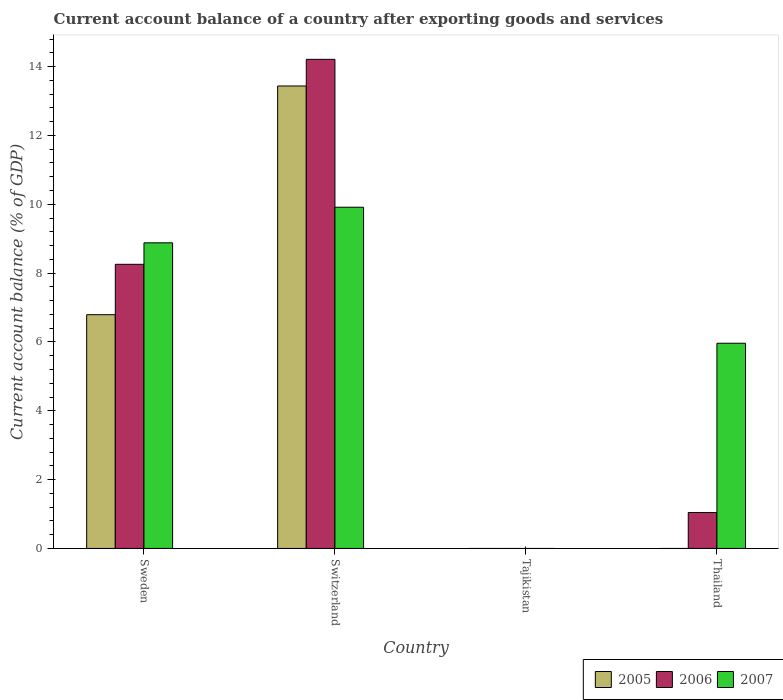How many different coloured bars are there?
Provide a short and direct response. 3. Are the number of bars on each tick of the X-axis equal?
Your answer should be very brief. No. How many bars are there on the 2nd tick from the right?
Offer a very short reply. 0. What is the label of the 4th group of bars from the left?
Ensure brevity in your answer.  Thailand. In how many cases, is the number of bars for a given country not equal to the number of legend labels?
Ensure brevity in your answer.  2. What is the account balance in 2005 in Sweden?
Offer a very short reply. 6.79. Across all countries, what is the maximum account balance in 2005?
Provide a succinct answer. 13.44. Across all countries, what is the minimum account balance in 2007?
Keep it short and to the point. 0. In which country was the account balance in 2005 maximum?
Your response must be concise. Switzerland. What is the total account balance in 2006 in the graph?
Ensure brevity in your answer.  23.51. What is the difference between the account balance in 2007 in Switzerland and that in Thailand?
Provide a short and direct response. 3.95. What is the difference between the account balance in 2006 in Switzerland and the account balance in 2005 in Thailand?
Your answer should be compact. 14.21. What is the average account balance in 2006 per country?
Offer a very short reply. 5.88. What is the difference between the account balance of/in 2007 and account balance of/in 2006 in Thailand?
Keep it short and to the point. 4.92. In how many countries, is the account balance in 2005 greater than 1.6 %?
Provide a succinct answer. 2. What is the ratio of the account balance in 2007 in Sweden to that in Thailand?
Your answer should be very brief. 1.49. Is the account balance in 2006 in Switzerland less than that in Thailand?
Your answer should be compact. No. Is the difference between the account balance in 2007 in Switzerland and Thailand greater than the difference between the account balance in 2006 in Switzerland and Thailand?
Your answer should be compact. No. What is the difference between the highest and the second highest account balance in 2006?
Make the answer very short. 7.21. What is the difference between the highest and the lowest account balance in 2006?
Give a very brief answer. 14.21. Is the sum of the account balance in 2007 in Sweden and Switzerland greater than the maximum account balance in 2006 across all countries?
Keep it short and to the point. Yes. Are the values on the major ticks of Y-axis written in scientific E-notation?
Your answer should be compact. No. Does the graph contain any zero values?
Offer a very short reply. Yes. Where does the legend appear in the graph?
Keep it short and to the point. Bottom right. What is the title of the graph?
Keep it short and to the point. Current account balance of a country after exporting goods and services. What is the label or title of the X-axis?
Keep it short and to the point. Country. What is the label or title of the Y-axis?
Keep it short and to the point. Current account balance (% of GDP). What is the Current account balance (% of GDP) in 2005 in Sweden?
Your response must be concise. 6.79. What is the Current account balance (% of GDP) in 2006 in Sweden?
Offer a terse response. 8.26. What is the Current account balance (% of GDP) in 2007 in Sweden?
Provide a succinct answer. 8.88. What is the Current account balance (% of GDP) in 2005 in Switzerland?
Make the answer very short. 13.44. What is the Current account balance (% of GDP) of 2006 in Switzerland?
Give a very brief answer. 14.21. What is the Current account balance (% of GDP) in 2007 in Switzerland?
Keep it short and to the point. 9.91. What is the Current account balance (% of GDP) of 2006 in Tajikistan?
Your response must be concise. 0. What is the Current account balance (% of GDP) of 2007 in Tajikistan?
Offer a terse response. 0. What is the Current account balance (% of GDP) in 2005 in Thailand?
Keep it short and to the point. 0. What is the Current account balance (% of GDP) in 2006 in Thailand?
Your answer should be very brief. 1.04. What is the Current account balance (% of GDP) of 2007 in Thailand?
Provide a succinct answer. 5.96. Across all countries, what is the maximum Current account balance (% of GDP) in 2005?
Offer a very short reply. 13.44. Across all countries, what is the maximum Current account balance (% of GDP) in 2006?
Your answer should be very brief. 14.21. Across all countries, what is the maximum Current account balance (% of GDP) of 2007?
Your answer should be very brief. 9.91. Across all countries, what is the minimum Current account balance (% of GDP) of 2006?
Provide a short and direct response. 0. What is the total Current account balance (% of GDP) of 2005 in the graph?
Keep it short and to the point. 20.23. What is the total Current account balance (% of GDP) of 2006 in the graph?
Provide a succinct answer. 23.51. What is the total Current account balance (% of GDP) of 2007 in the graph?
Offer a very short reply. 24.76. What is the difference between the Current account balance (% of GDP) of 2005 in Sweden and that in Switzerland?
Provide a short and direct response. -6.65. What is the difference between the Current account balance (% of GDP) in 2006 in Sweden and that in Switzerland?
Keep it short and to the point. -5.96. What is the difference between the Current account balance (% of GDP) in 2007 in Sweden and that in Switzerland?
Offer a very short reply. -1.03. What is the difference between the Current account balance (% of GDP) in 2006 in Sweden and that in Thailand?
Provide a short and direct response. 7.21. What is the difference between the Current account balance (% of GDP) of 2007 in Sweden and that in Thailand?
Make the answer very short. 2.92. What is the difference between the Current account balance (% of GDP) of 2006 in Switzerland and that in Thailand?
Keep it short and to the point. 13.17. What is the difference between the Current account balance (% of GDP) of 2007 in Switzerland and that in Thailand?
Ensure brevity in your answer.  3.95. What is the difference between the Current account balance (% of GDP) in 2005 in Sweden and the Current account balance (% of GDP) in 2006 in Switzerland?
Keep it short and to the point. -7.42. What is the difference between the Current account balance (% of GDP) in 2005 in Sweden and the Current account balance (% of GDP) in 2007 in Switzerland?
Keep it short and to the point. -3.12. What is the difference between the Current account balance (% of GDP) of 2006 in Sweden and the Current account balance (% of GDP) of 2007 in Switzerland?
Your response must be concise. -1.66. What is the difference between the Current account balance (% of GDP) of 2005 in Sweden and the Current account balance (% of GDP) of 2006 in Thailand?
Your answer should be very brief. 5.75. What is the difference between the Current account balance (% of GDP) of 2005 in Sweden and the Current account balance (% of GDP) of 2007 in Thailand?
Offer a terse response. 0.83. What is the difference between the Current account balance (% of GDP) in 2006 in Sweden and the Current account balance (% of GDP) in 2007 in Thailand?
Your answer should be compact. 2.29. What is the difference between the Current account balance (% of GDP) in 2005 in Switzerland and the Current account balance (% of GDP) in 2006 in Thailand?
Your answer should be compact. 12.39. What is the difference between the Current account balance (% of GDP) in 2005 in Switzerland and the Current account balance (% of GDP) in 2007 in Thailand?
Make the answer very short. 7.48. What is the difference between the Current account balance (% of GDP) in 2006 in Switzerland and the Current account balance (% of GDP) in 2007 in Thailand?
Your answer should be very brief. 8.25. What is the average Current account balance (% of GDP) of 2005 per country?
Ensure brevity in your answer.  5.06. What is the average Current account balance (% of GDP) in 2006 per country?
Provide a succinct answer. 5.88. What is the average Current account balance (% of GDP) of 2007 per country?
Provide a short and direct response. 6.19. What is the difference between the Current account balance (% of GDP) of 2005 and Current account balance (% of GDP) of 2006 in Sweden?
Offer a very short reply. -1.46. What is the difference between the Current account balance (% of GDP) of 2005 and Current account balance (% of GDP) of 2007 in Sweden?
Make the answer very short. -2.09. What is the difference between the Current account balance (% of GDP) of 2006 and Current account balance (% of GDP) of 2007 in Sweden?
Ensure brevity in your answer.  -0.62. What is the difference between the Current account balance (% of GDP) of 2005 and Current account balance (% of GDP) of 2006 in Switzerland?
Your answer should be very brief. -0.77. What is the difference between the Current account balance (% of GDP) in 2005 and Current account balance (% of GDP) in 2007 in Switzerland?
Make the answer very short. 3.52. What is the difference between the Current account balance (% of GDP) in 2006 and Current account balance (% of GDP) in 2007 in Switzerland?
Make the answer very short. 4.3. What is the difference between the Current account balance (% of GDP) in 2006 and Current account balance (% of GDP) in 2007 in Thailand?
Ensure brevity in your answer.  -4.92. What is the ratio of the Current account balance (% of GDP) in 2005 in Sweden to that in Switzerland?
Keep it short and to the point. 0.51. What is the ratio of the Current account balance (% of GDP) of 2006 in Sweden to that in Switzerland?
Provide a succinct answer. 0.58. What is the ratio of the Current account balance (% of GDP) in 2007 in Sweden to that in Switzerland?
Your answer should be compact. 0.9. What is the ratio of the Current account balance (% of GDP) in 2006 in Sweden to that in Thailand?
Keep it short and to the point. 7.9. What is the ratio of the Current account balance (% of GDP) in 2007 in Sweden to that in Thailand?
Keep it short and to the point. 1.49. What is the ratio of the Current account balance (% of GDP) of 2006 in Switzerland to that in Thailand?
Offer a very short reply. 13.61. What is the ratio of the Current account balance (% of GDP) of 2007 in Switzerland to that in Thailand?
Offer a terse response. 1.66. What is the difference between the highest and the second highest Current account balance (% of GDP) of 2006?
Offer a very short reply. 5.96. What is the difference between the highest and the second highest Current account balance (% of GDP) of 2007?
Keep it short and to the point. 1.03. What is the difference between the highest and the lowest Current account balance (% of GDP) of 2005?
Give a very brief answer. 13.44. What is the difference between the highest and the lowest Current account balance (% of GDP) of 2006?
Offer a terse response. 14.21. What is the difference between the highest and the lowest Current account balance (% of GDP) of 2007?
Make the answer very short. 9.91. 